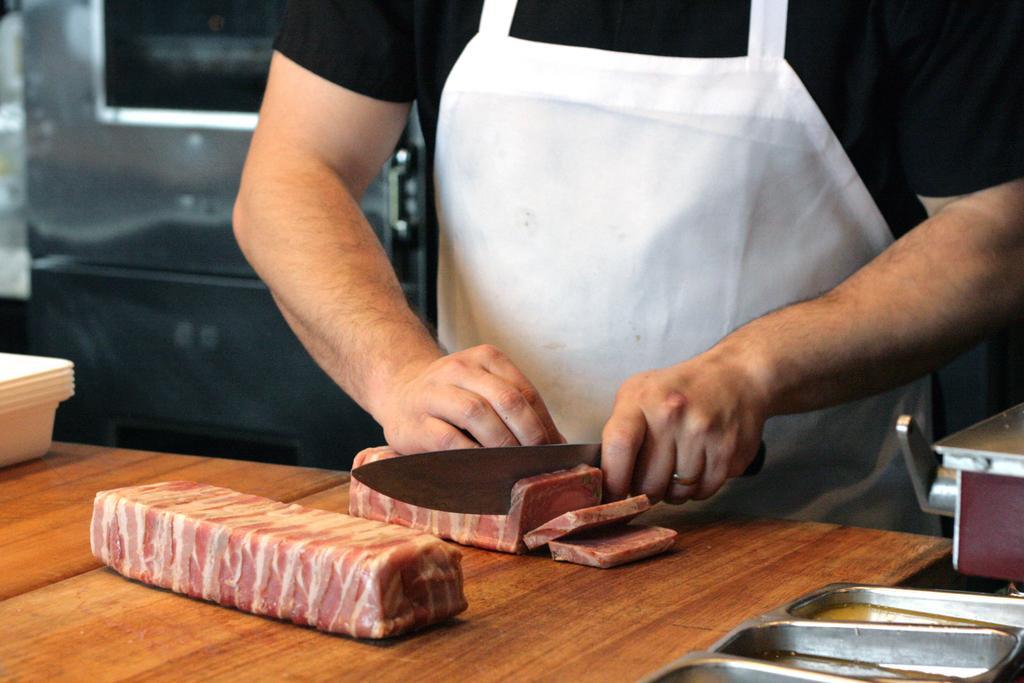Can you describe this image briefly? In this image we can see a person wearing black T-shirt and white color apron is holding a knife in his hand and cutting the meat which is placed on the wooden table. Here we can see a steel plate in which we can see food items and white color plates placed on the table. In the background, we can see a microwave. 